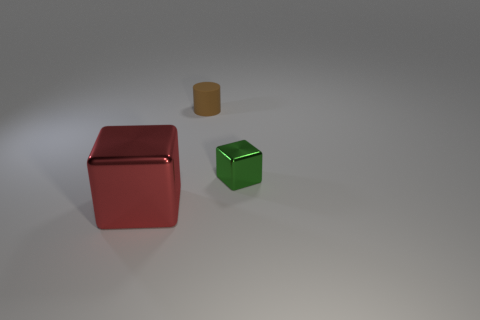Add 2 cubes. How many objects exist? 5 Subtract all cylinders. How many objects are left? 2 Subtract 1 cylinders. How many cylinders are left? 0 Subtract 0 brown cubes. How many objects are left? 3 Subtract all gray cubes. Subtract all blue cylinders. How many cubes are left? 2 Subtract all cyan blocks. How many blue cylinders are left? 0 Subtract all large red cubes. Subtract all small metal things. How many objects are left? 1 Add 2 brown rubber cylinders. How many brown rubber cylinders are left? 3 Add 2 large blocks. How many large blocks exist? 3 